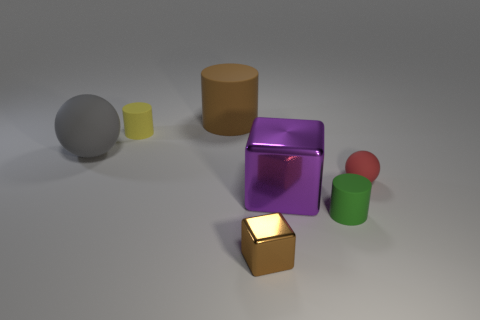Are there more big cyan metal cylinders than green objects?
Your response must be concise. No. What number of objects are in front of the small yellow cylinder and behind the small brown shiny cube?
Your answer should be very brief. 4. What number of cylinders are behind the tiny matte cylinder in front of the large rubber ball?
Offer a very short reply. 2. There is a matte sphere that is on the right side of the tiny brown block; is its size the same as the matte ball that is left of the large purple shiny block?
Keep it short and to the point. No. What number of brown matte balls are there?
Offer a very short reply. 0. What number of other spheres have the same material as the tiny red sphere?
Offer a very short reply. 1. Are there an equal number of tiny blocks behind the tiny green matte cylinder and small yellow rubber blocks?
Provide a succinct answer. Yes. What is the material of the large thing that is the same color as the small metallic object?
Give a very brief answer. Rubber. There is a brown cylinder; does it have the same size as the rubber sphere that is right of the gray rubber thing?
Offer a very short reply. No. How many other objects are there of the same size as the yellow object?
Give a very brief answer. 3. 